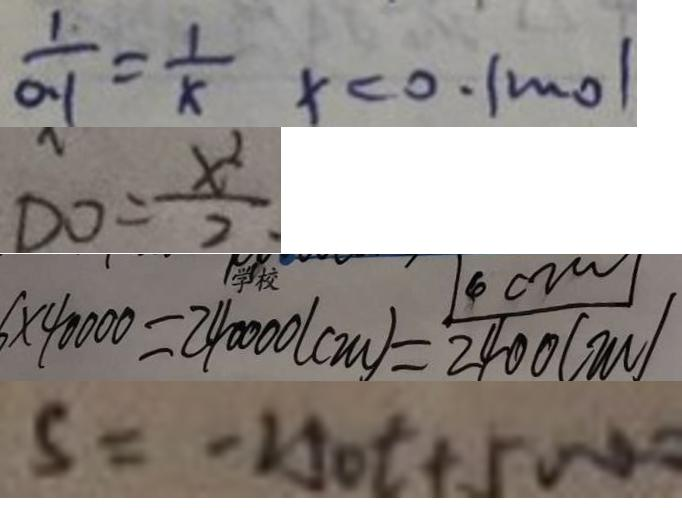<formula> <loc_0><loc_0><loc_500><loc_500>\frac { 1 } { 0 . 1 } = \frac { 1 } { x } x < 0 . 1 m o l 
 D 0 = \frac { x ^ { 2 } } { 2 } 
 6 \times 4 0 0 0 0 = 2 4 0 0 0 0 ( c m ) = \frac { 1 4 0 0 0 } { 2 4 0 0 ( m ) } 
 5 = - 2 5 0 t + 5 0 0 0</formula> 